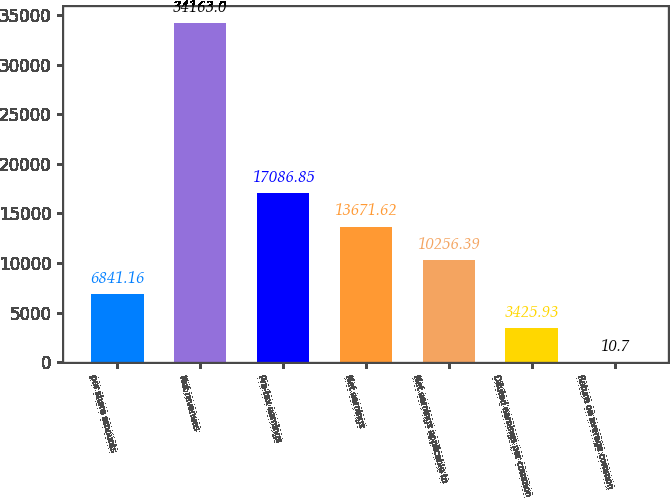Convert chart. <chart><loc_0><loc_0><loc_500><loc_500><bar_chart><fcel>per share amounts<fcel>Net revenues<fcel>Pre-tax earnings<fcel>Net earnings<fcel>Net earnings applicable to<fcel>Diluted earnings per common<fcel>Return on average common<nl><fcel>6841.16<fcel>34163<fcel>17086.8<fcel>13671.6<fcel>10256.4<fcel>3425.93<fcel>10.7<nl></chart> 